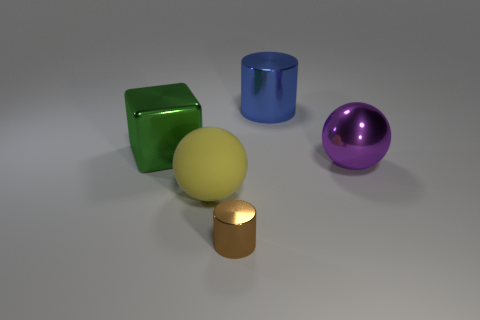Are there an equal number of big cubes behind the blue cylinder and big yellow rubber balls?
Provide a succinct answer. No. How many other things are there of the same color as the tiny metal cylinder?
Offer a very short reply. 0. The metal thing that is in front of the cube and behind the tiny brown cylinder is what color?
Ensure brevity in your answer.  Purple. There is a cylinder behind the sphere to the right of the large ball to the left of the large purple metal ball; how big is it?
Make the answer very short. Large. What number of things are things in front of the big yellow rubber thing or big things in front of the large purple shiny thing?
Your answer should be very brief. 2. What is the shape of the big yellow object?
Ensure brevity in your answer.  Sphere. What number of other objects are there of the same material as the big cube?
Your answer should be compact. 3. The other thing that is the same shape as the blue metallic object is what size?
Your response must be concise. Small. What material is the large ball in front of the shiny object that is to the right of the metallic cylinder that is behind the big purple shiny object?
Your answer should be compact. Rubber. Are there any small cyan matte balls?
Make the answer very short. No. 